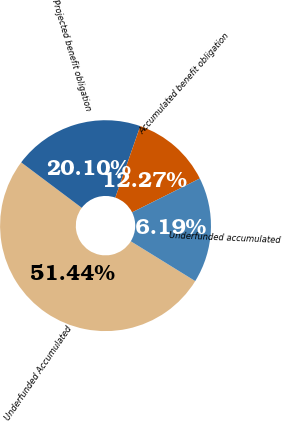Convert chart. <chart><loc_0><loc_0><loc_500><loc_500><pie_chart><fcel>Underfunded Accumulated<fcel>Projected benefit obligation<fcel>Accumulated benefit obligation<fcel>Underfunded accumulated<nl><fcel>51.44%<fcel>20.1%<fcel>12.27%<fcel>16.19%<nl></chart> 